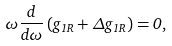<formula> <loc_0><loc_0><loc_500><loc_500>\omega \frac { d } { d \omega } \left ( g _ { 1 R } + \Delta g _ { 1 R } \right ) = 0 ,</formula> 